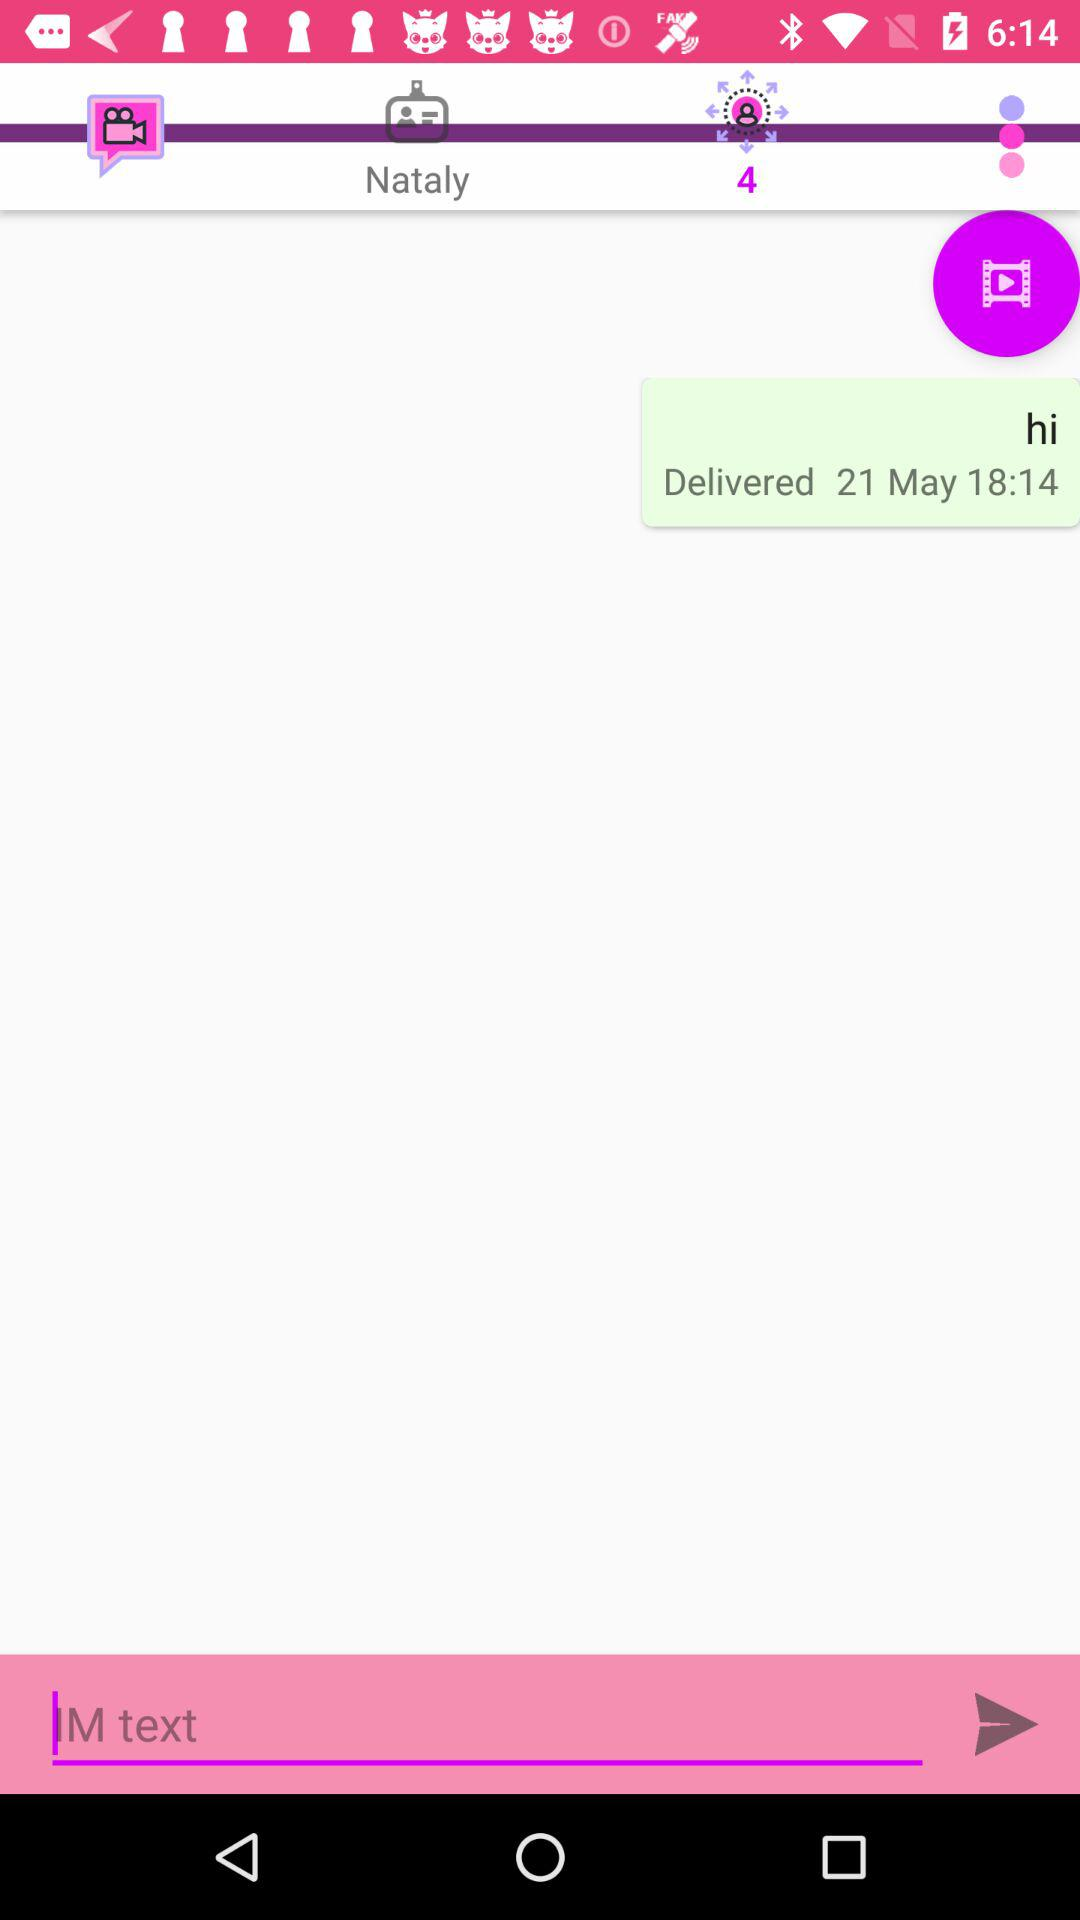What is the message delivery time? The message delivery time is 18:14. 